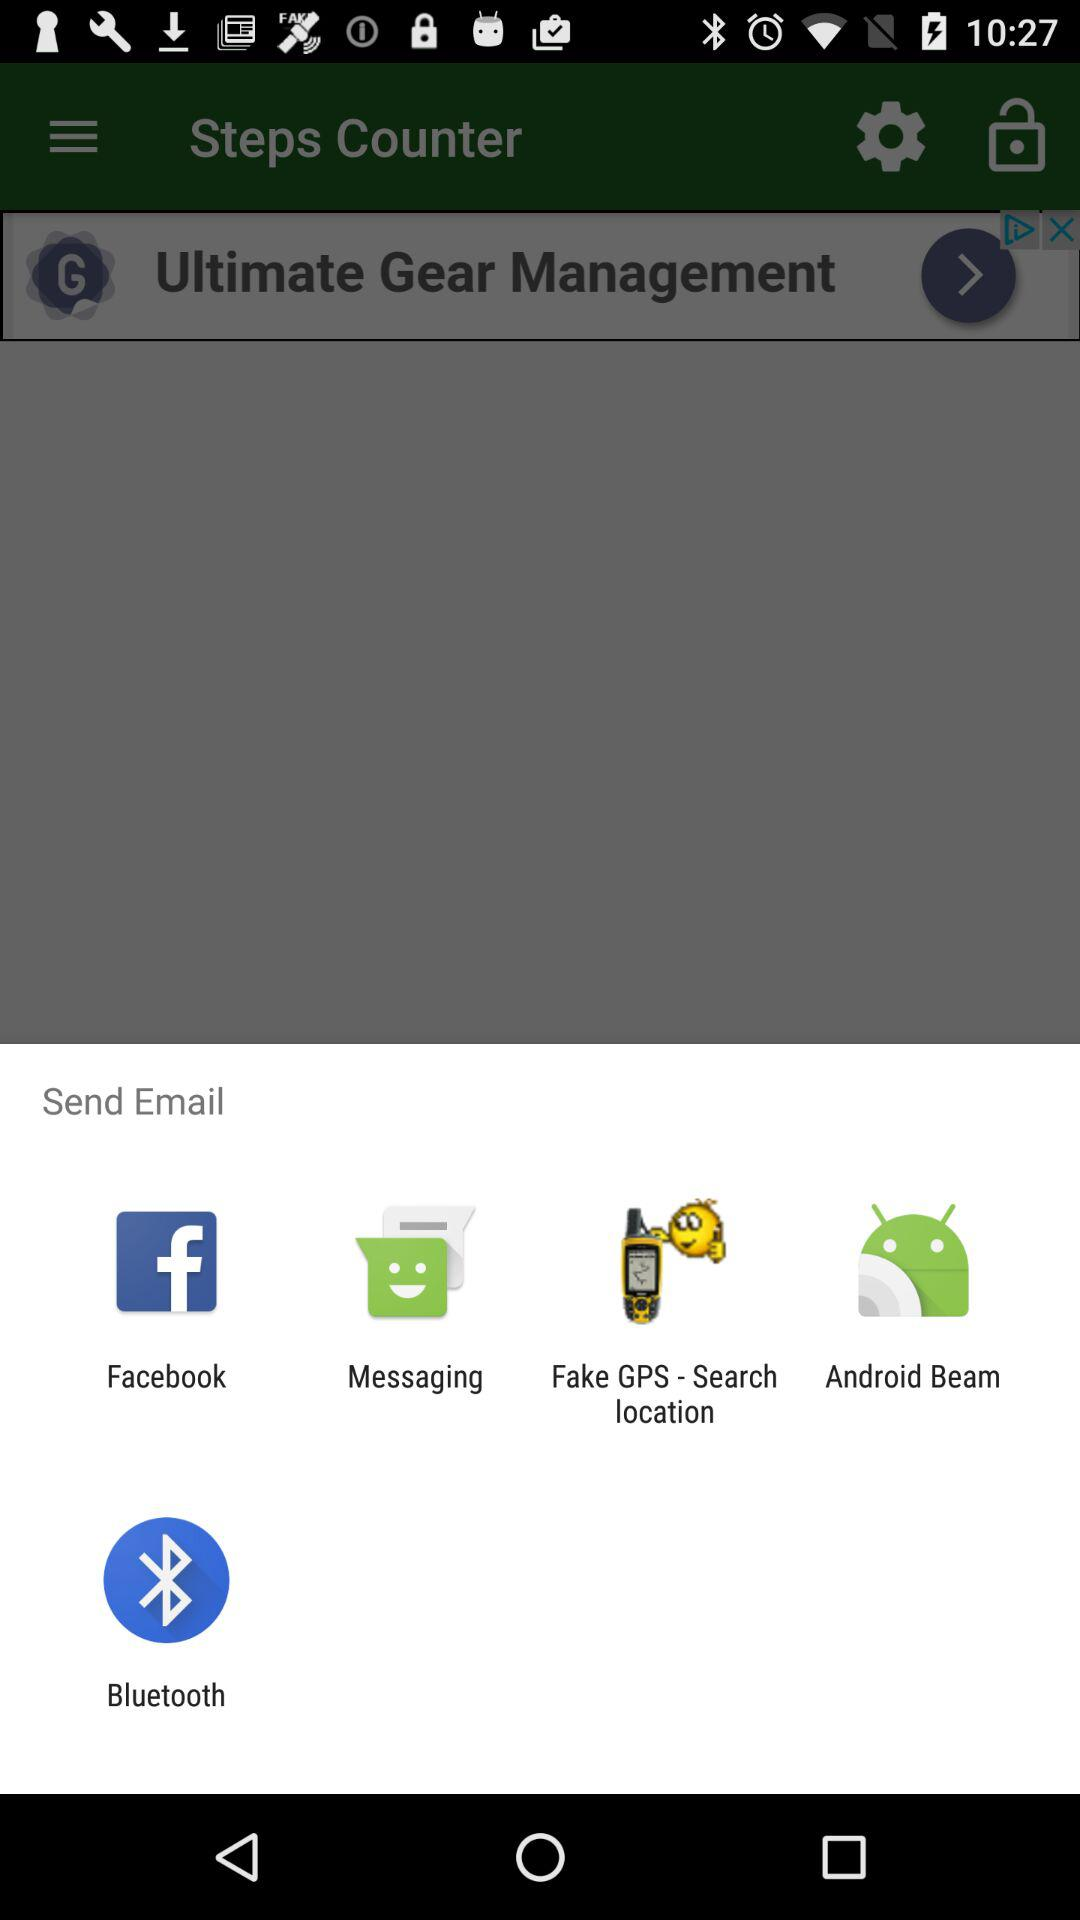Which applications can be used to send email? The applications are "Facebook", " Messaging", "Fake GPS - Search location", "Android Beam" and "Bluetooth". 